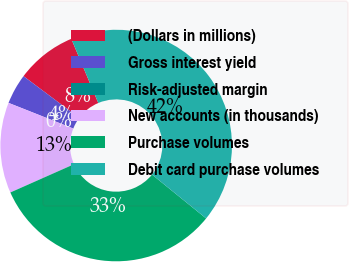Convert chart to OTSL. <chart><loc_0><loc_0><loc_500><loc_500><pie_chart><fcel>(Dollars in millions)<fcel>Gross interest yield<fcel>Risk-adjusted margin<fcel>New accounts (in thousands)<fcel>Purchase volumes<fcel>Debit card purchase volumes<nl><fcel>8.44%<fcel>4.22%<fcel>0.0%<fcel>12.65%<fcel>32.52%<fcel>42.18%<nl></chart> 